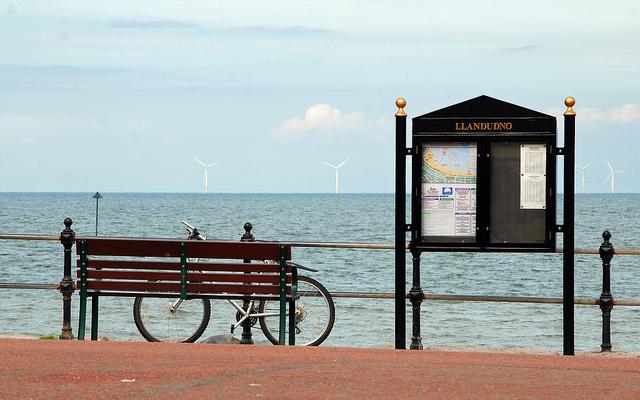Is this a summer scene?
Concise answer only. Yes. Where is the bench?
Concise answer only. On other side of fence. Is this view beautiful?
Write a very short answer. Yes. Is the bench facing the ocean?
Give a very brief answer. Yes. 